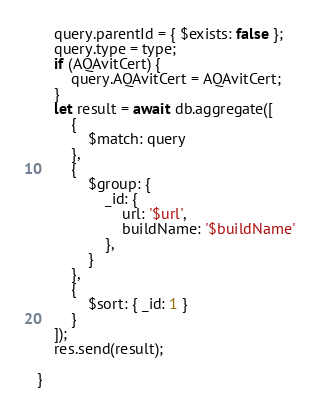<code> <loc_0><loc_0><loc_500><loc_500><_JavaScript_>    query.parentId = { $exists: false };
    query.type = type;
    if (AQAvitCert) {
        query.AQAvitCert = AQAvitCert;
    }
    let result = await db.aggregate([
        {
            $match: query
        },
        {
            $group: {
                _id: {
                    url: '$url',
                    buildName: '$buildName'
                },
            }
        },
        {
            $sort: { _id: 1 }
        }
    ]);
    res.send(result);
 
}</code> 